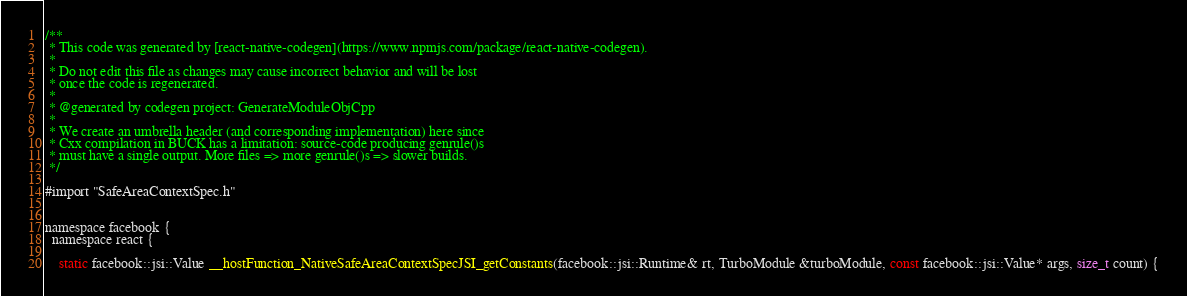Convert code to text. <code><loc_0><loc_0><loc_500><loc_500><_ObjectiveC_>/**
 * This code was generated by [react-native-codegen](https://www.npmjs.com/package/react-native-codegen).
 *
 * Do not edit this file as changes may cause incorrect behavior and will be lost
 * once the code is regenerated.
 *
 * @generated by codegen project: GenerateModuleObjCpp
 *
 * We create an umbrella header (and corresponding implementation) here since
 * Cxx compilation in BUCK has a limitation: source-code producing genrule()s
 * must have a single output. More files => more genrule()s => slower builds.
 */

#import "SafeAreaContextSpec.h"


namespace facebook {
  namespace react {
    
    static facebook::jsi::Value __hostFunction_NativeSafeAreaContextSpecJSI_getConstants(facebook::jsi::Runtime& rt, TurboModule &turboModule, const facebook::jsi::Value* args, size_t count) {</code> 